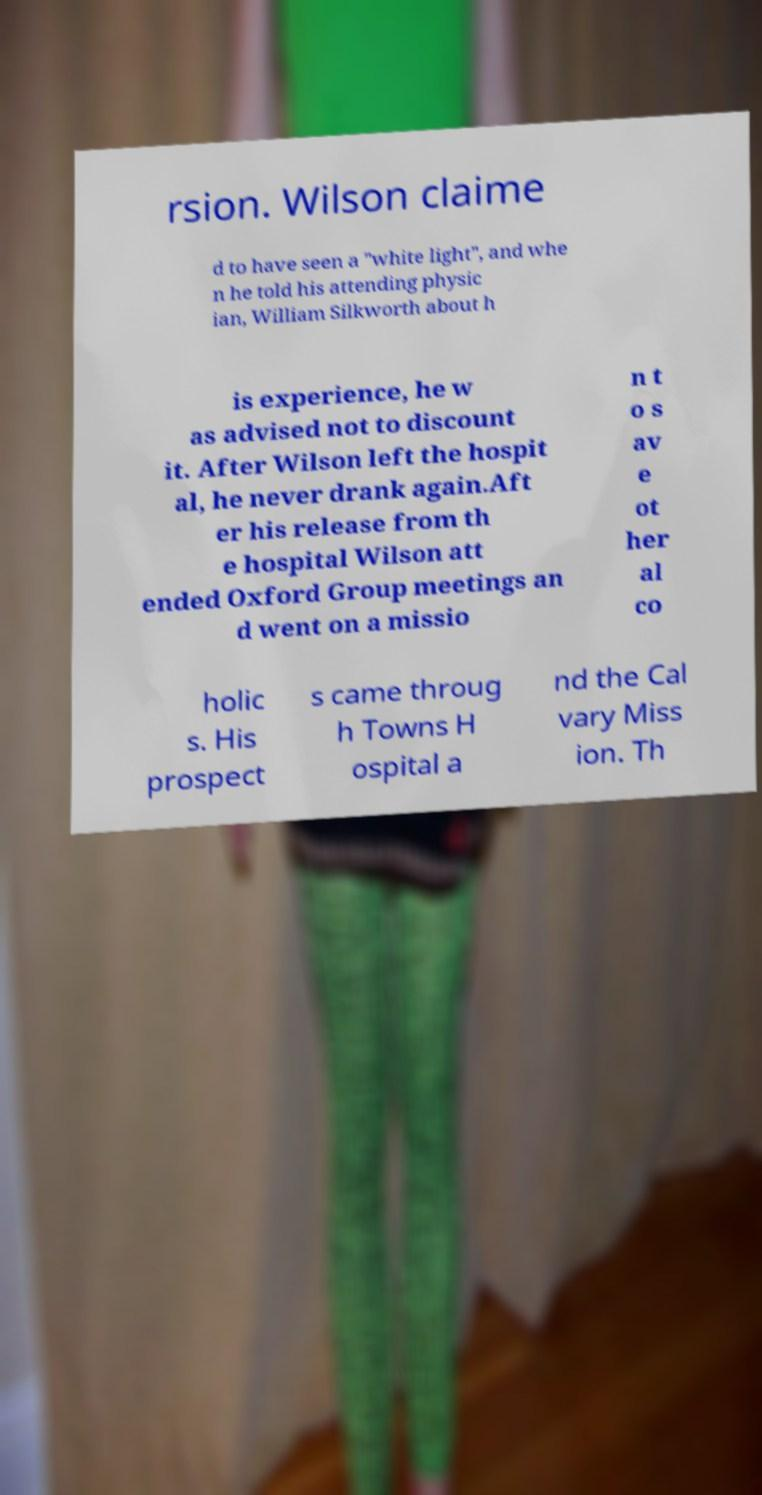Please read and relay the text visible in this image. What does it say? rsion. Wilson claime d to have seen a "white light", and whe n he told his attending physic ian, William Silkworth about h is experience, he w as advised not to discount it. After Wilson left the hospit al, he never drank again.Aft er his release from th e hospital Wilson att ended Oxford Group meetings an d went on a missio n t o s av e ot her al co holic s. His prospect s came throug h Towns H ospital a nd the Cal vary Miss ion. Th 